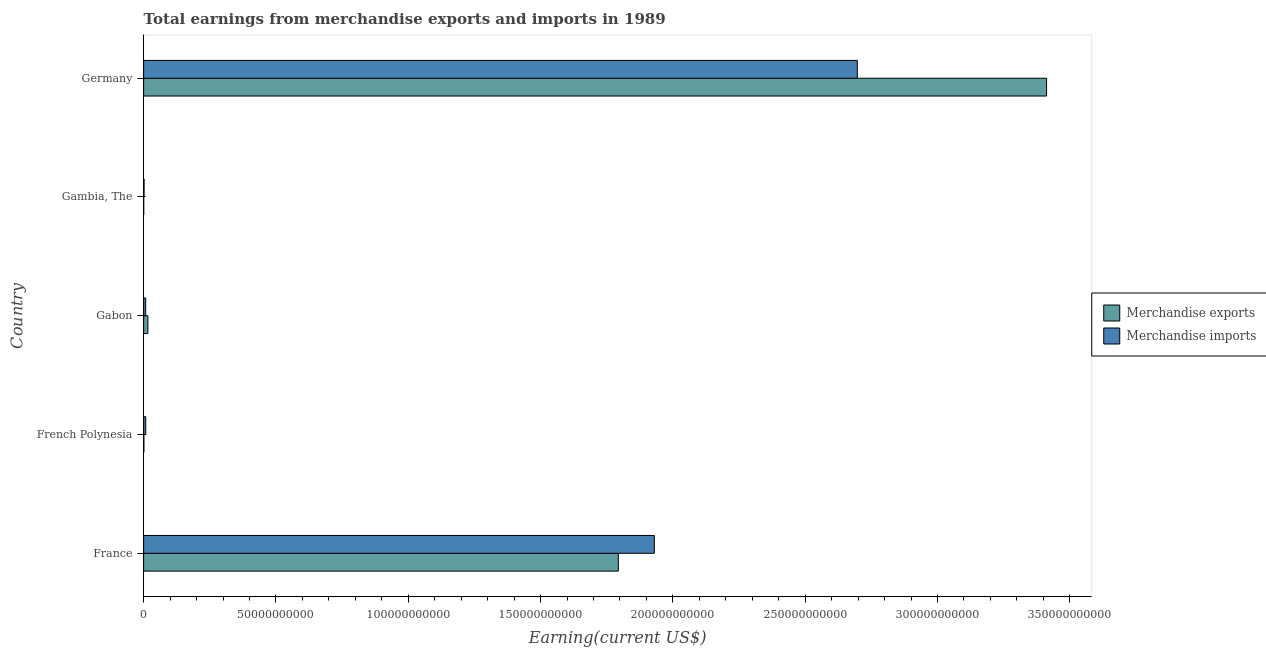Are the number of bars per tick equal to the number of legend labels?
Offer a terse response. Yes. Are the number of bars on each tick of the Y-axis equal?
Provide a short and direct response. Yes. What is the label of the 5th group of bars from the top?
Give a very brief answer. France. What is the earnings from merchandise exports in French Polynesia?
Ensure brevity in your answer.  8.90e+07. Across all countries, what is the maximum earnings from merchandise imports?
Offer a terse response. 2.70e+11. Across all countries, what is the minimum earnings from merchandise exports?
Make the answer very short. 2.70e+07. In which country was the earnings from merchandise exports maximum?
Your answer should be compact. Germany. In which country was the earnings from merchandise exports minimum?
Ensure brevity in your answer.  Gambia, The. What is the total earnings from merchandise exports in the graph?
Your answer should be very brief. 5.22e+11. What is the difference between the earnings from merchandise exports in French Polynesia and that in Gabon?
Your response must be concise. -1.51e+09. What is the difference between the earnings from merchandise exports in Gambia, The and the earnings from merchandise imports in French Polynesia?
Offer a very short reply. -7.63e+08. What is the average earnings from merchandise exports per country?
Make the answer very short. 1.04e+11. What is the difference between the earnings from merchandise exports and earnings from merchandise imports in Germany?
Ensure brevity in your answer.  7.15e+1. What is the ratio of the earnings from merchandise exports in Gabon to that in Germany?
Ensure brevity in your answer.  0.01. Is the difference between the earnings from merchandise imports in France and Gabon greater than the difference between the earnings from merchandise exports in France and Gabon?
Keep it short and to the point. Yes. What is the difference between the highest and the second highest earnings from merchandise imports?
Keep it short and to the point. 7.67e+1. What is the difference between the highest and the lowest earnings from merchandise imports?
Ensure brevity in your answer.  2.70e+11. In how many countries, is the earnings from merchandise exports greater than the average earnings from merchandise exports taken over all countries?
Provide a succinct answer. 2. What does the 1st bar from the top in French Polynesia represents?
Make the answer very short. Merchandise imports. How many bars are there?
Offer a terse response. 10. Are all the bars in the graph horizontal?
Ensure brevity in your answer.  Yes. Are the values on the major ticks of X-axis written in scientific E-notation?
Offer a very short reply. No. Does the graph contain any zero values?
Your response must be concise. No. Where does the legend appear in the graph?
Provide a short and direct response. Center right. What is the title of the graph?
Make the answer very short. Total earnings from merchandise exports and imports in 1989. Does "Private funds" appear as one of the legend labels in the graph?
Provide a succinct answer. No. What is the label or title of the X-axis?
Your answer should be very brief. Earning(current US$). What is the Earning(current US$) of Merchandise exports in France?
Offer a very short reply. 1.79e+11. What is the Earning(current US$) of Merchandise imports in France?
Ensure brevity in your answer.  1.93e+11. What is the Earning(current US$) in Merchandise exports in French Polynesia?
Make the answer very short. 8.90e+07. What is the Earning(current US$) in Merchandise imports in French Polynesia?
Your answer should be very brief. 7.90e+08. What is the Earning(current US$) of Merchandise exports in Gabon?
Your answer should be very brief. 1.60e+09. What is the Earning(current US$) of Merchandise imports in Gabon?
Your answer should be very brief. 7.67e+08. What is the Earning(current US$) in Merchandise exports in Gambia, The?
Offer a terse response. 2.70e+07. What is the Earning(current US$) in Merchandise imports in Gambia, The?
Your answer should be very brief. 1.61e+08. What is the Earning(current US$) in Merchandise exports in Germany?
Keep it short and to the point. 3.41e+11. What is the Earning(current US$) of Merchandise imports in Germany?
Your response must be concise. 2.70e+11. Across all countries, what is the maximum Earning(current US$) in Merchandise exports?
Offer a very short reply. 3.41e+11. Across all countries, what is the maximum Earning(current US$) in Merchandise imports?
Keep it short and to the point. 2.70e+11. Across all countries, what is the minimum Earning(current US$) of Merchandise exports?
Make the answer very short. 2.70e+07. Across all countries, what is the minimum Earning(current US$) of Merchandise imports?
Give a very brief answer. 1.61e+08. What is the total Earning(current US$) in Merchandise exports in the graph?
Your response must be concise. 5.22e+11. What is the total Earning(current US$) of Merchandise imports in the graph?
Your answer should be very brief. 4.64e+11. What is the difference between the Earning(current US$) of Merchandise exports in France and that in French Polynesia?
Your answer should be compact. 1.79e+11. What is the difference between the Earning(current US$) of Merchandise imports in France and that in French Polynesia?
Make the answer very short. 1.92e+11. What is the difference between the Earning(current US$) of Merchandise exports in France and that in Gabon?
Your answer should be very brief. 1.78e+11. What is the difference between the Earning(current US$) in Merchandise imports in France and that in Gabon?
Offer a very short reply. 1.92e+11. What is the difference between the Earning(current US$) of Merchandise exports in France and that in Gambia, The?
Make the answer very short. 1.79e+11. What is the difference between the Earning(current US$) of Merchandise imports in France and that in Gambia, The?
Provide a short and direct response. 1.93e+11. What is the difference between the Earning(current US$) of Merchandise exports in France and that in Germany?
Offer a very short reply. -1.62e+11. What is the difference between the Earning(current US$) in Merchandise imports in France and that in Germany?
Ensure brevity in your answer.  -7.67e+1. What is the difference between the Earning(current US$) of Merchandise exports in French Polynesia and that in Gabon?
Give a very brief answer. -1.51e+09. What is the difference between the Earning(current US$) of Merchandise imports in French Polynesia and that in Gabon?
Offer a very short reply. 2.30e+07. What is the difference between the Earning(current US$) in Merchandise exports in French Polynesia and that in Gambia, The?
Your answer should be very brief. 6.20e+07. What is the difference between the Earning(current US$) in Merchandise imports in French Polynesia and that in Gambia, The?
Provide a short and direct response. 6.29e+08. What is the difference between the Earning(current US$) of Merchandise exports in French Polynesia and that in Germany?
Give a very brief answer. -3.41e+11. What is the difference between the Earning(current US$) of Merchandise imports in French Polynesia and that in Germany?
Your response must be concise. -2.69e+11. What is the difference between the Earning(current US$) of Merchandise exports in Gabon and that in Gambia, The?
Your answer should be very brief. 1.57e+09. What is the difference between the Earning(current US$) in Merchandise imports in Gabon and that in Gambia, The?
Keep it short and to the point. 6.06e+08. What is the difference between the Earning(current US$) of Merchandise exports in Gabon and that in Germany?
Ensure brevity in your answer.  -3.40e+11. What is the difference between the Earning(current US$) in Merchandise imports in Gabon and that in Germany?
Provide a short and direct response. -2.69e+11. What is the difference between the Earning(current US$) of Merchandise exports in Gambia, The and that in Germany?
Keep it short and to the point. -3.41e+11. What is the difference between the Earning(current US$) of Merchandise imports in Gambia, The and that in Germany?
Offer a very short reply. -2.70e+11. What is the difference between the Earning(current US$) in Merchandise exports in France and the Earning(current US$) in Merchandise imports in French Polynesia?
Offer a terse response. 1.79e+11. What is the difference between the Earning(current US$) of Merchandise exports in France and the Earning(current US$) of Merchandise imports in Gabon?
Give a very brief answer. 1.79e+11. What is the difference between the Earning(current US$) of Merchandise exports in France and the Earning(current US$) of Merchandise imports in Gambia, The?
Your answer should be very brief. 1.79e+11. What is the difference between the Earning(current US$) in Merchandise exports in France and the Earning(current US$) in Merchandise imports in Germany?
Your answer should be very brief. -9.03e+1. What is the difference between the Earning(current US$) of Merchandise exports in French Polynesia and the Earning(current US$) of Merchandise imports in Gabon?
Your answer should be very brief. -6.78e+08. What is the difference between the Earning(current US$) of Merchandise exports in French Polynesia and the Earning(current US$) of Merchandise imports in Gambia, The?
Keep it short and to the point. -7.20e+07. What is the difference between the Earning(current US$) in Merchandise exports in French Polynesia and the Earning(current US$) in Merchandise imports in Germany?
Offer a terse response. -2.70e+11. What is the difference between the Earning(current US$) of Merchandise exports in Gabon and the Earning(current US$) of Merchandise imports in Gambia, The?
Your answer should be compact. 1.44e+09. What is the difference between the Earning(current US$) of Merchandise exports in Gabon and the Earning(current US$) of Merchandise imports in Germany?
Make the answer very short. -2.68e+11. What is the difference between the Earning(current US$) of Merchandise exports in Gambia, The and the Earning(current US$) of Merchandise imports in Germany?
Give a very brief answer. -2.70e+11. What is the average Earning(current US$) of Merchandise exports per country?
Your answer should be compact. 1.04e+11. What is the average Earning(current US$) in Merchandise imports per country?
Offer a very short reply. 9.29e+1. What is the difference between the Earning(current US$) of Merchandise exports and Earning(current US$) of Merchandise imports in France?
Provide a short and direct response. -1.36e+1. What is the difference between the Earning(current US$) of Merchandise exports and Earning(current US$) of Merchandise imports in French Polynesia?
Give a very brief answer. -7.01e+08. What is the difference between the Earning(current US$) in Merchandise exports and Earning(current US$) in Merchandise imports in Gabon?
Your answer should be compact. 8.31e+08. What is the difference between the Earning(current US$) in Merchandise exports and Earning(current US$) in Merchandise imports in Gambia, The?
Provide a succinct answer. -1.34e+08. What is the difference between the Earning(current US$) in Merchandise exports and Earning(current US$) in Merchandise imports in Germany?
Your answer should be very brief. 7.15e+1. What is the ratio of the Earning(current US$) of Merchandise exports in France to that in French Polynesia?
Offer a terse response. 2015.7. What is the ratio of the Earning(current US$) of Merchandise imports in France to that in French Polynesia?
Give a very brief answer. 244.29. What is the ratio of the Earning(current US$) in Merchandise exports in France to that in Gabon?
Give a very brief answer. 112.26. What is the ratio of the Earning(current US$) of Merchandise imports in France to that in Gabon?
Your response must be concise. 251.61. What is the ratio of the Earning(current US$) in Merchandise exports in France to that in Gambia, The?
Make the answer very short. 6644.33. What is the ratio of the Earning(current US$) of Merchandise imports in France to that in Gambia, The?
Ensure brevity in your answer.  1198.67. What is the ratio of the Earning(current US$) of Merchandise exports in France to that in Germany?
Offer a very short reply. 0.53. What is the ratio of the Earning(current US$) of Merchandise imports in France to that in Germany?
Give a very brief answer. 0.72. What is the ratio of the Earning(current US$) in Merchandise exports in French Polynesia to that in Gabon?
Your answer should be compact. 0.06. What is the ratio of the Earning(current US$) in Merchandise imports in French Polynesia to that in Gabon?
Your response must be concise. 1.03. What is the ratio of the Earning(current US$) of Merchandise exports in French Polynesia to that in Gambia, The?
Provide a succinct answer. 3.3. What is the ratio of the Earning(current US$) of Merchandise imports in French Polynesia to that in Gambia, The?
Offer a terse response. 4.91. What is the ratio of the Earning(current US$) in Merchandise imports in French Polynesia to that in Germany?
Your response must be concise. 0. What is the ratio of the Earning(current US$) of Merchandise exports in Gabon to that in Gambia, The?
Offer a very short reply. 59.19. What is the ratio of the Earning(current US$) of Merchandise imports in Gabon to that in Gambia, The?
Keep it short and to the point. 4.76. What is the ratio of the Earning(current US$) of Merchandise exports in Gabon to that in Germany?
Keep it short and to the point. 0. What is the ratio of the Earning(current US$) of Merchandise imports in Gabon to that in Germany?
Offer a terse response. 0. What is the ratio of the Earning(current US$) in Merchandise imports in Gambia, The to that in Germany?
Provide a succinct answer. 0. What is the difference between the highest and the second highest Earning(current US$) in Merchandise exports?
Your response must be concise. 1.62e+11. What is the difference between the highest and the second highest Earning(current US$) of Merchandise imports?
Offer a very short reply. 7.67e+1. What is the difference between the highest and the lowest Earning(current US$) of Merchandise exports?
Your answer should be compact. 3.41e+11. What is the difference between the highest and the lowest Earning(current US$) in Merchandise imports?
Offer a terse response. 2.70e+11. 